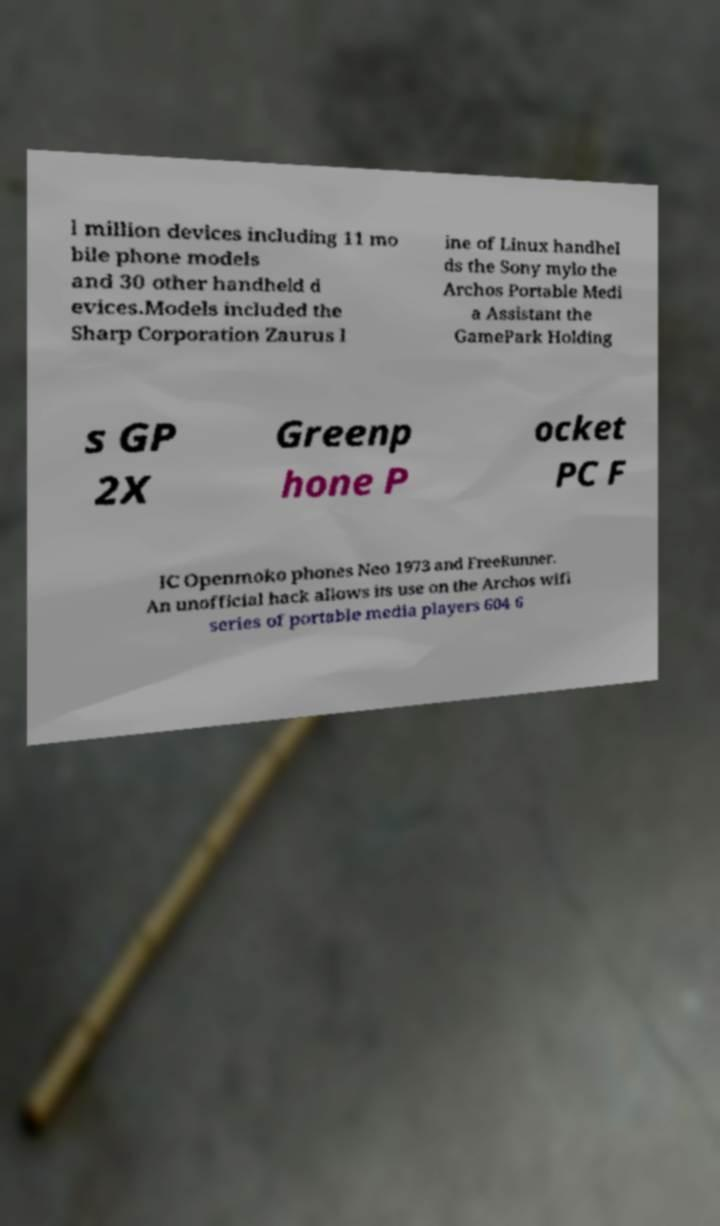Can you read and provide the text displayed in the image?This photo seems to have some interesting text. Can you extract and type it out for me? l million devices including 11 mo bile phone models and 30 other handheld d evices.Models included the Sharp Corporation Zaurus l ine of Linux handhel ds the Sony mylo the Archos Portable Medi a Assistant the GamePark Holding s GP 2X Greenp hone P ocket PC F IC Openmoko phones Neo 1973 and FreeRunner. An unofficial hack allows its use on the Archos wifi series of portable media players 604 6 